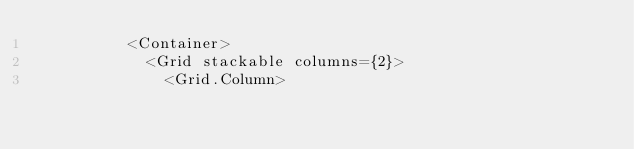Convert code to text. <code><loc_0><loc_0><loc_500><loc_500><_JavaScript_>          <Container>
            <Grid stackable columns={2}>
              <Grid.Column></code> 